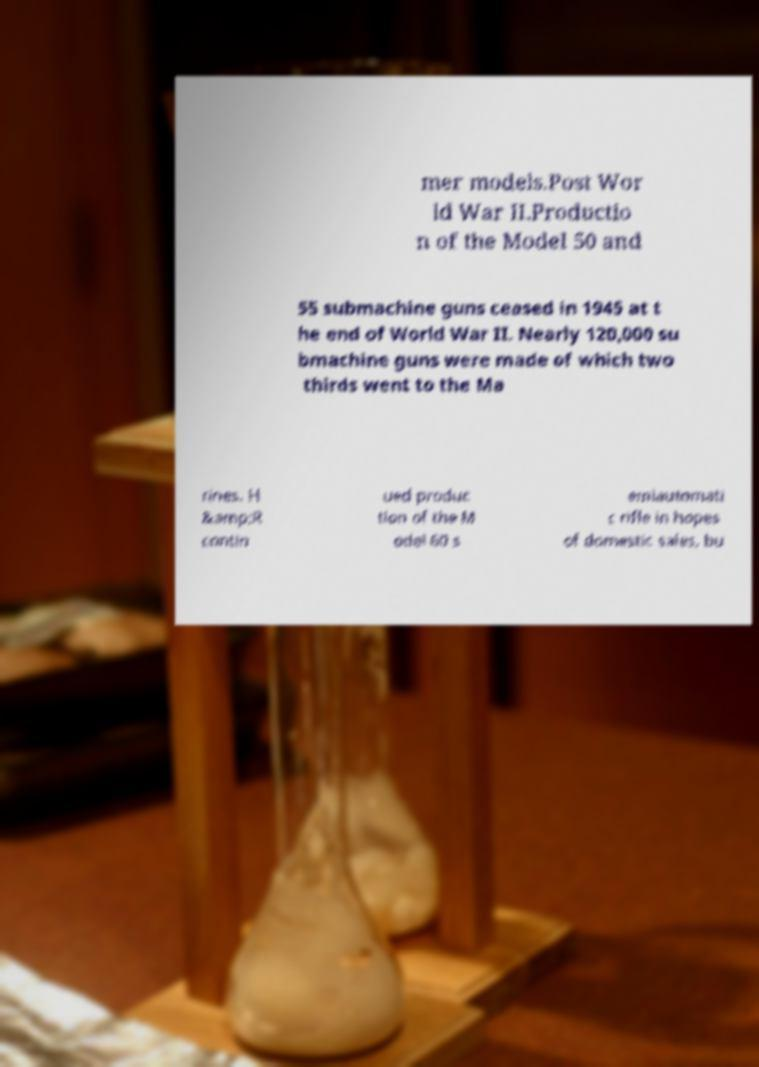Please read and relay the text visible in this image. What does it say? mer models.Post Wor ld War II.Productio n of the Model 50 and 55 submachine guns ceased in 1945 at t he end of World War II. Nearly 120,000 su bmachine guns were made of which two thirds went to the Ma rines. H &amp;R contin ued produc tion of the M odel 60 s emiautomati c rifle in hopes of domestic sales, bu 